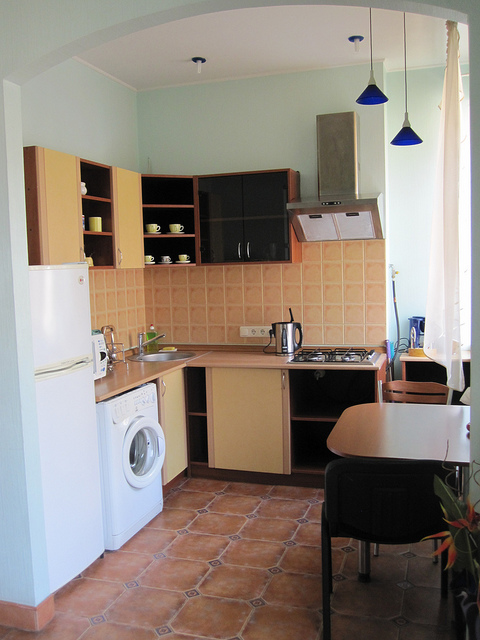<image>What is in the toaster? I am not sure what is in the toaster. It could be bread, toast, or nothing. What is in the toaster? I am not sure what is in the toaster. It can be bread or nothing. 